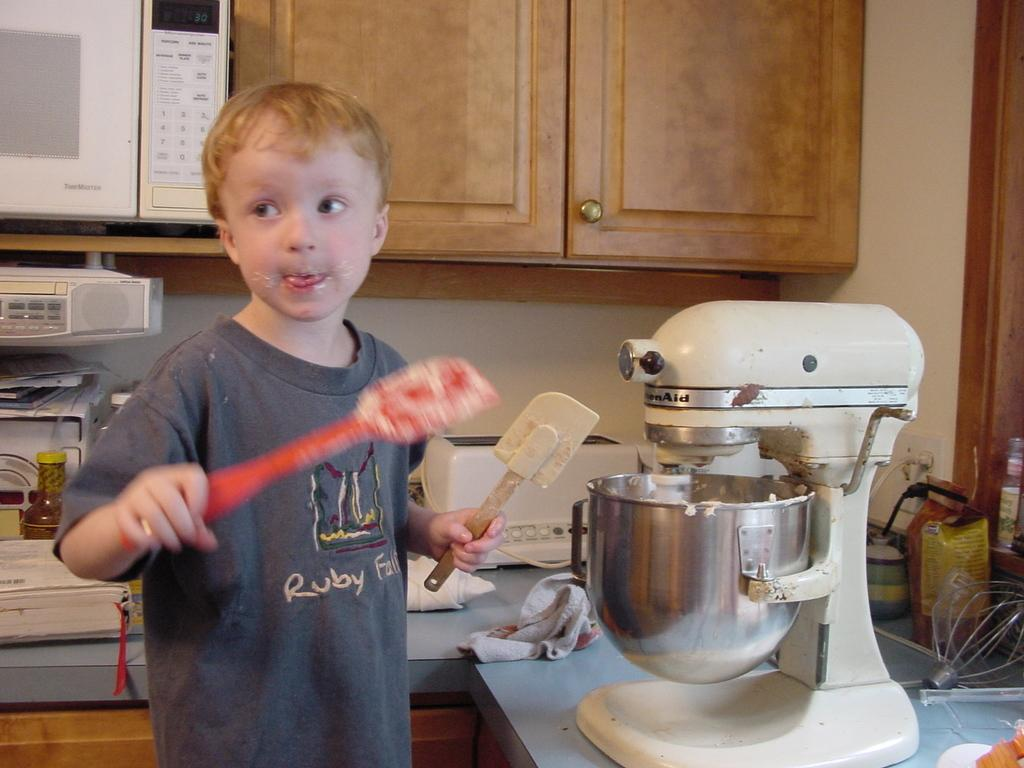<image>
Relay a brief, clear account of the picture shown. Ruby falls on a dark gray shirt on a kid. 